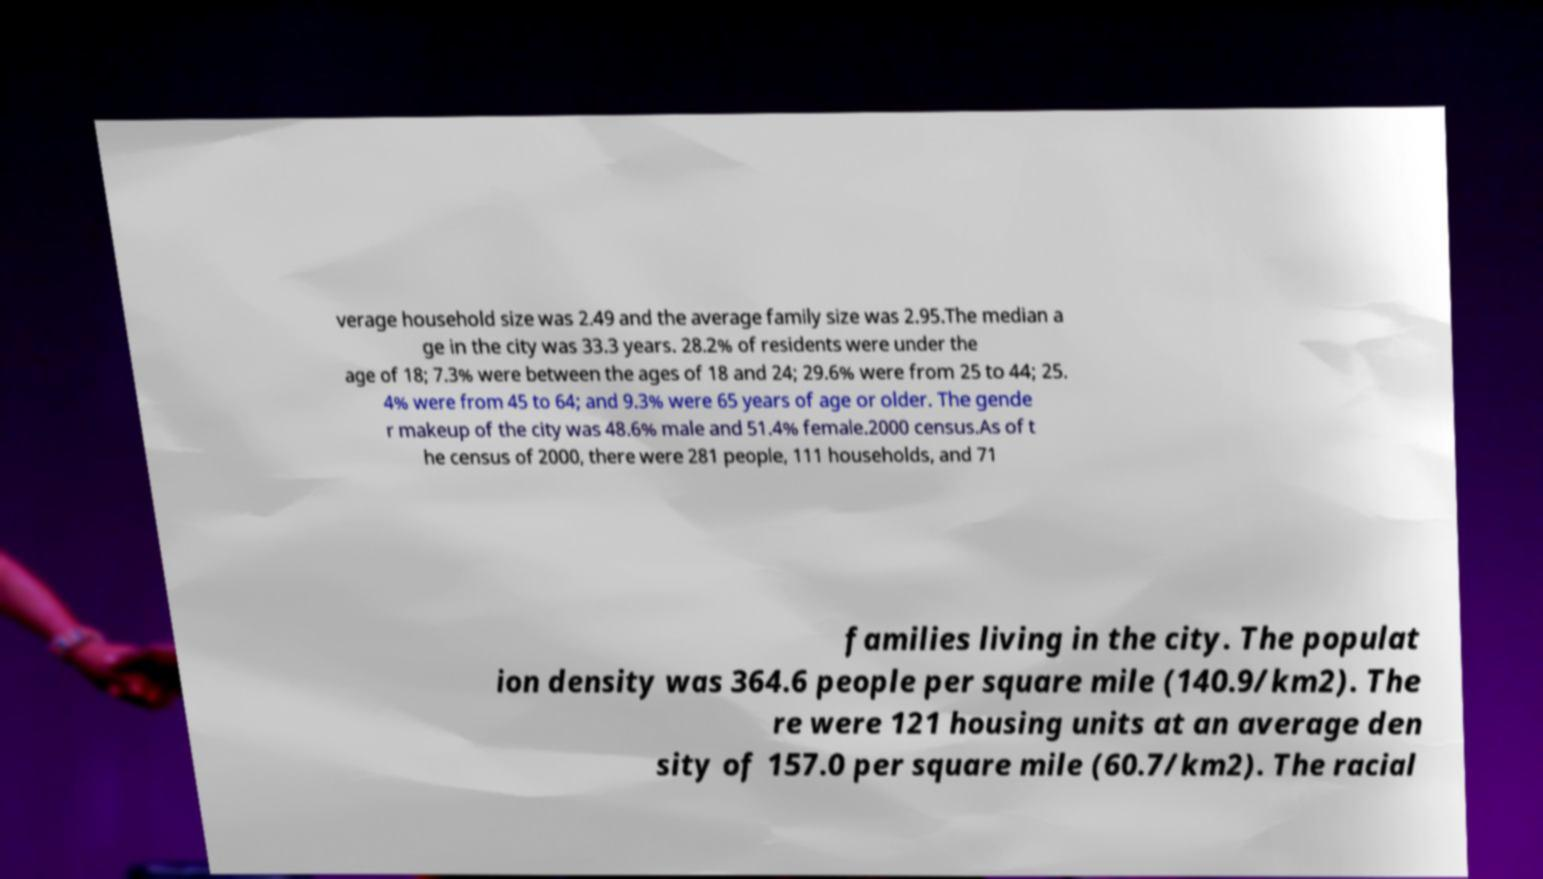Can you read and provide the text displayed in the image?This photo seems to have some interesting text. Can you extract and type it out for me? verage household size was 2.49 and the average family size was 2.95.The median a ge in the city was 33.3 years. 28.2% of residents were under the age of 18; 7.3% were between the ages of 18 and 24; 29.6% were from 25 to 44; 25. 4% were from 45 to 64; and 9.3% were 65 years of age or older. The gende r makeup of the city was 48.6% male and 51.4% female.2000 census.As of t he census of 2000, there were 281 people, 111 households, and 71 families living in the city. The populat ion density was 364.6 people per square mile (140.9/km2). The re were 121 housing units at an average den sity of 157.0 per square mile (60.7/km2). The racial 